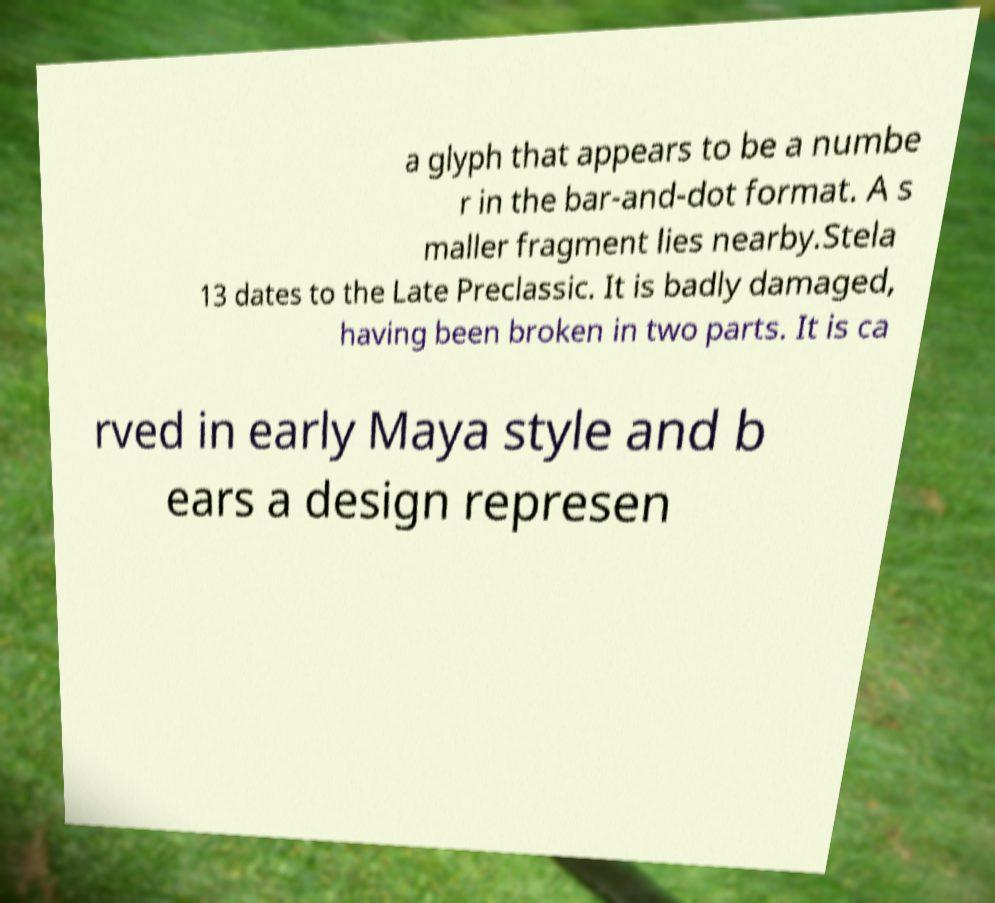Could you assist in decoding the text presented in this image and type it out clearly? a glyph that appears to be a numbe r in the bar-and-dot format. A s maller fragment lies nearby.Stela 13 dates to the Late Preclassic. It is badly damaged, having been broken in two parts. It is ca rved in early Maya style and b ears a design represen 